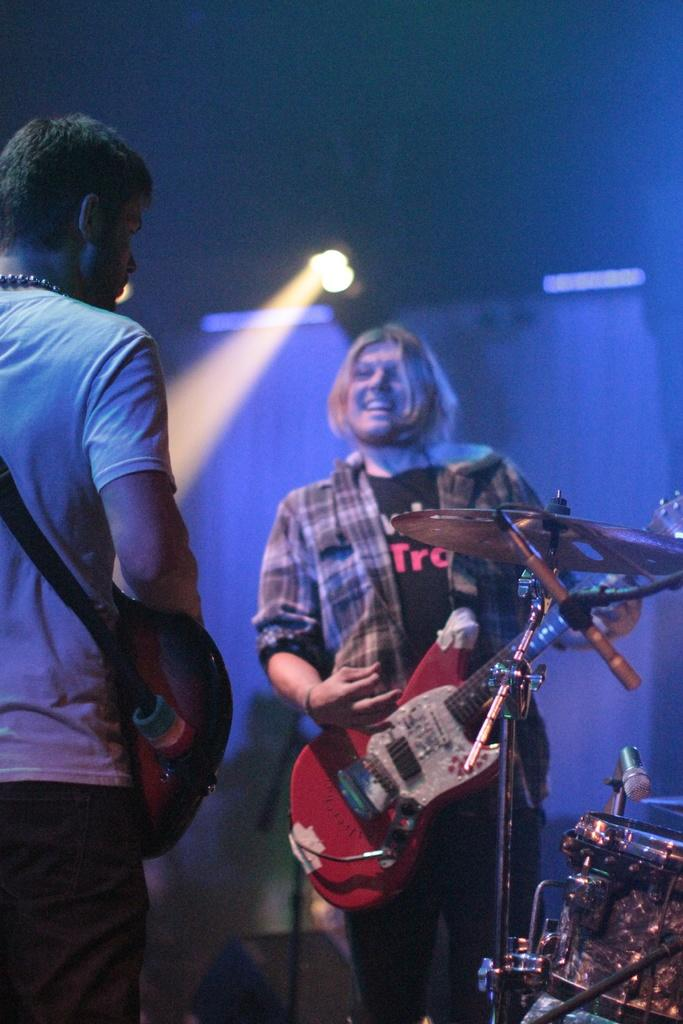How many people are in the image? There are two people in the image. What are the people holding in the image? Both people are holding guitars. Can you describe the facial expression of one of the people? One of the people is smiling. What type of advertisement is being displayed on the vessel in the image? There is no vessel or advertisement present in the image; it features two people holding guitars. What type of competition are the people participating in within the image? There is no competition present in the image; it simply shows two people holding guitars. 